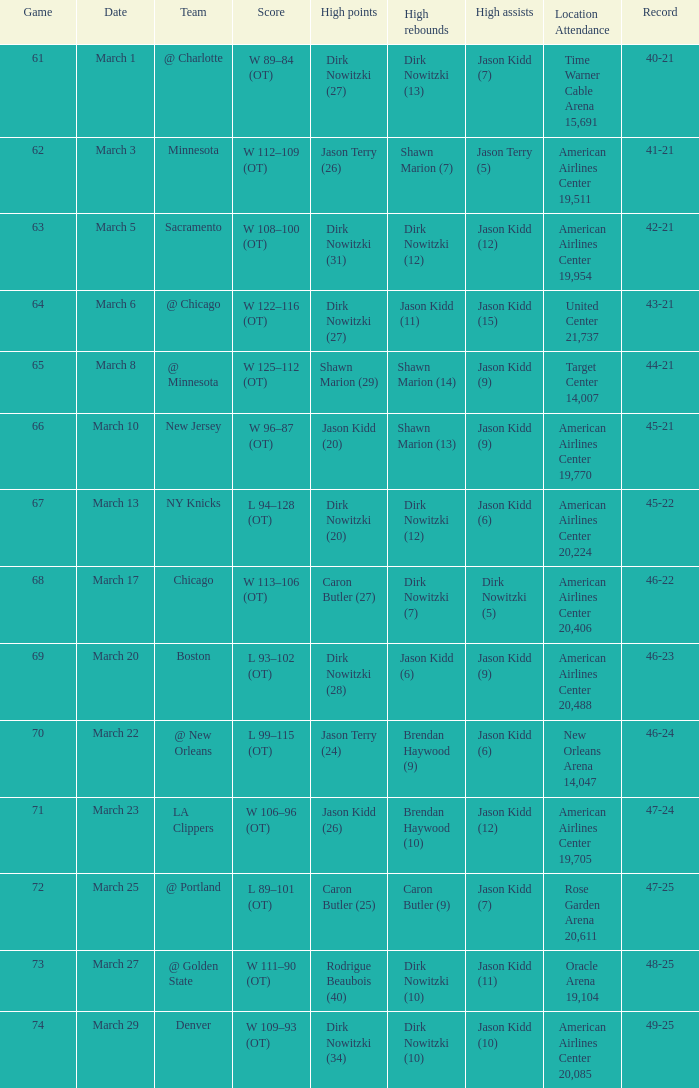How many contests occurred when the mavericks achieved a 46-22 record? 68.0. 